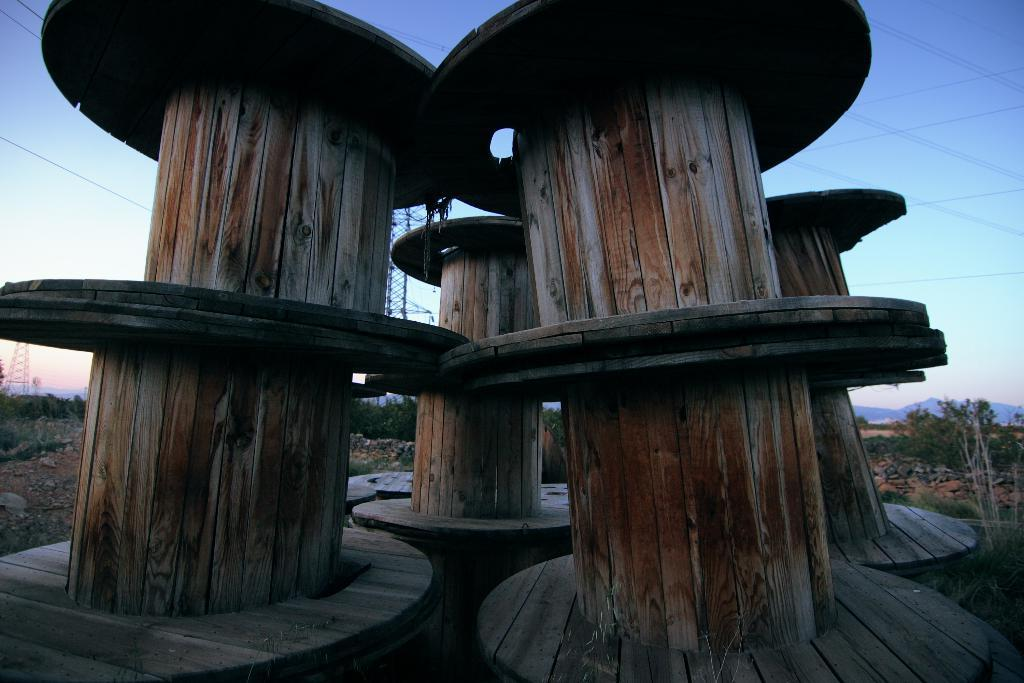What type of objects are in the image? There are wooden logs in the image. What can be seen in the background of the image? There are trees and towers in the background of the image. What type of rice is being served in the image? There is no rice present in the image; it features wooden logs and a background with trees and towers. What is the color of the milk in the image? There is no milk present in the image. 